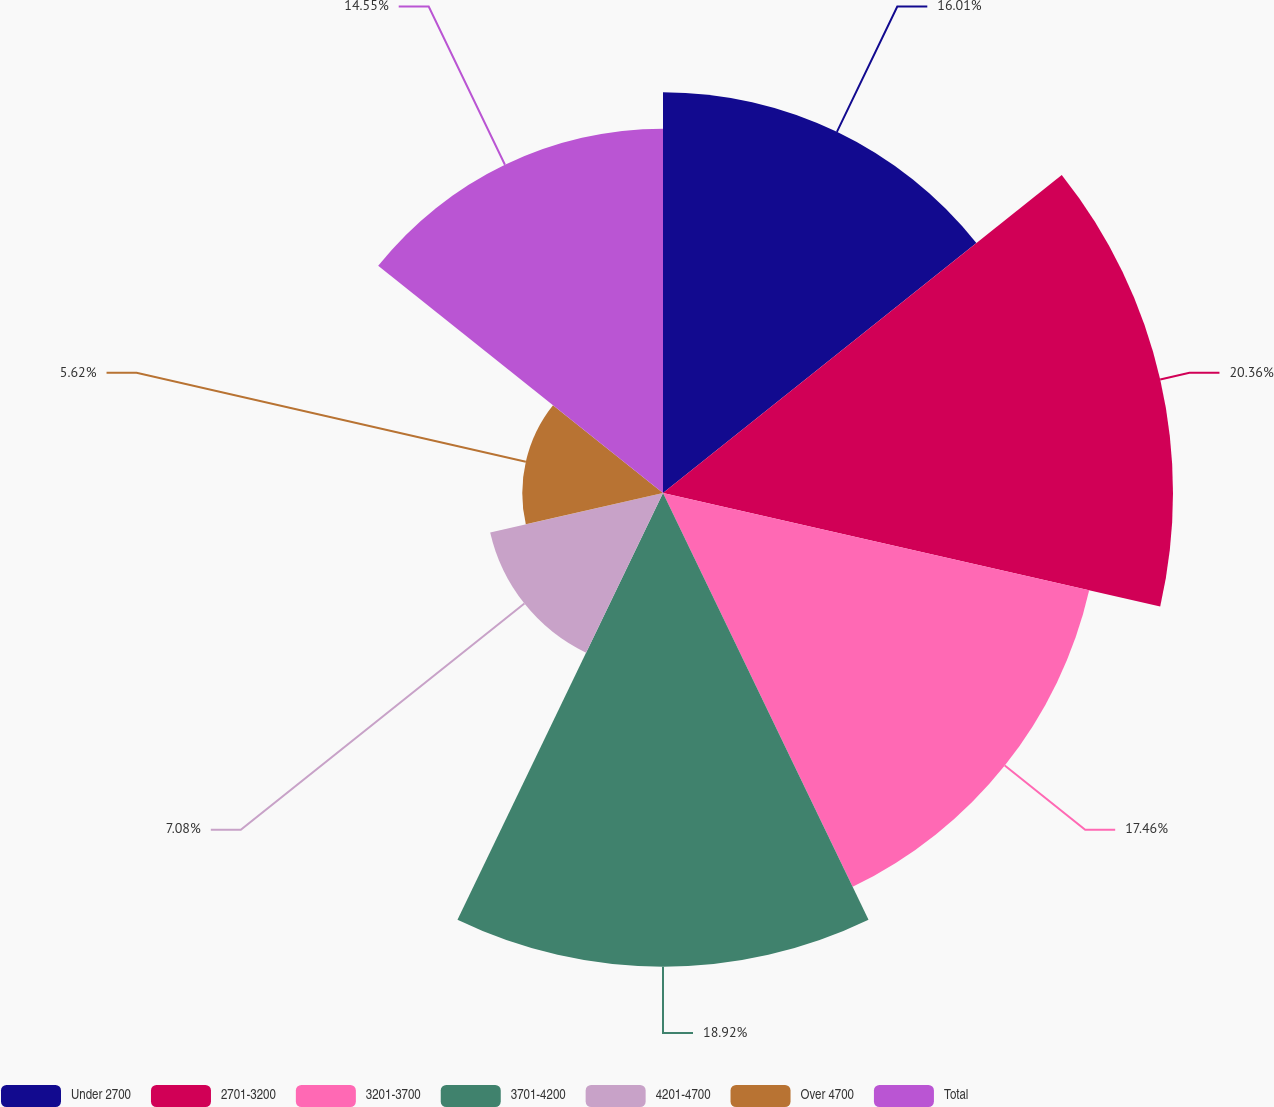Convert chart. <chart><loc_0><loc_0><loc_500><loc_500><pie_chart><fcel>Under 2700<fcel>2701-3200<fcel>3201-3700<fcel>3701-4200<fcel>4201-4700<fcel>Over 4700<fcel>Total<nl><fcel>16.01%<fcel>20.37%<fcel>17.46%<fcel>18.92%<fcel>7.08%<fcel>5.62%<fcel>14.55%<nl></chart> 